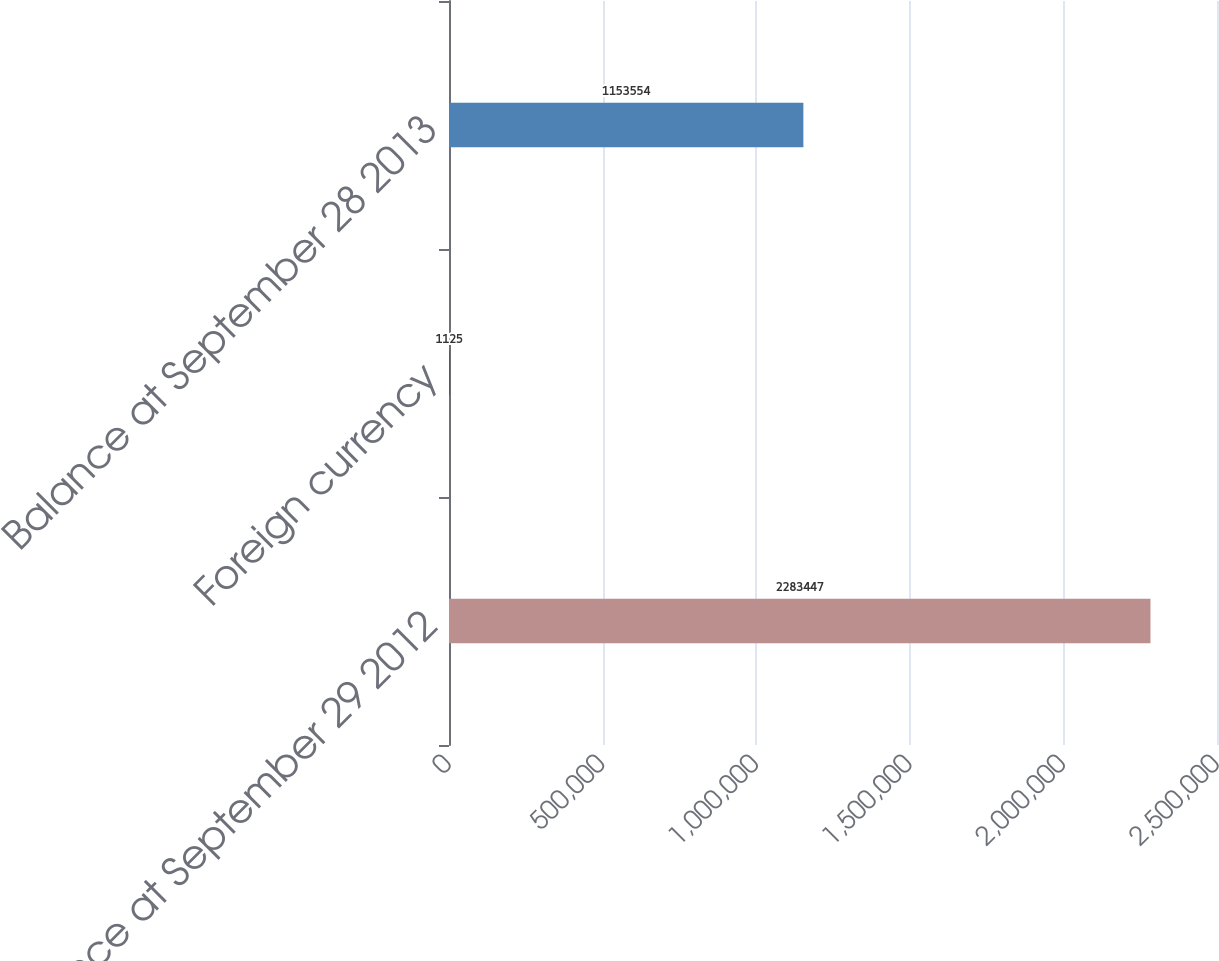<chart> <loc_0><loc_0><loc_500><loc_500><bar_chart><fcel>Balance at September 29 2012<fcel>Foreign currency<fcel>Balance at September 28 2013<nl><fcel>2.28345e+06<fcel>1125<fcel>1.15355e+06<nl></chart> 